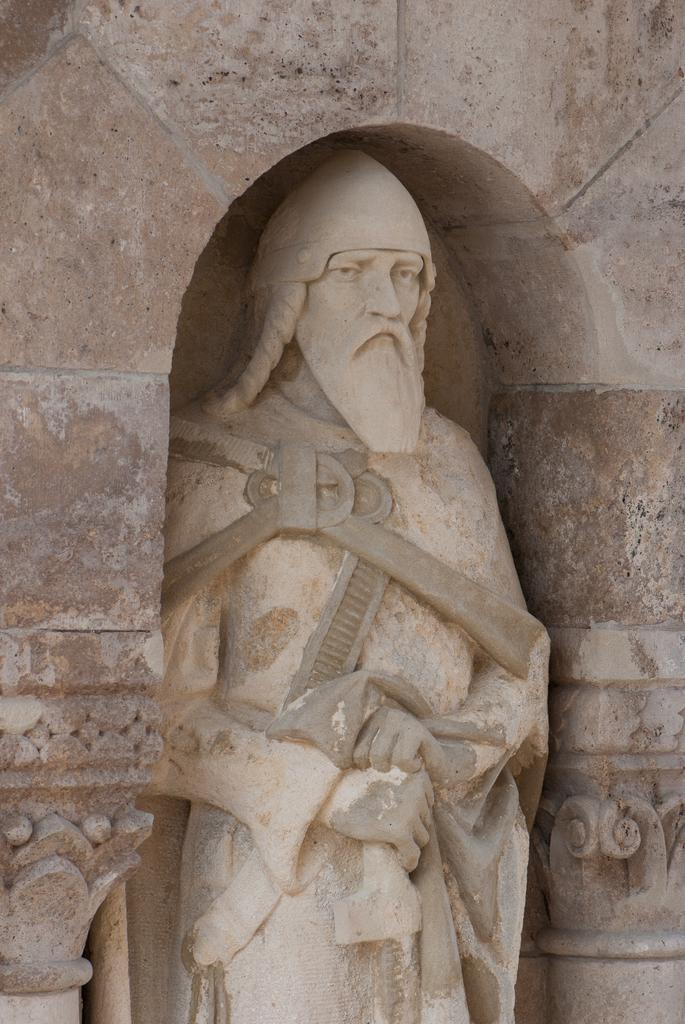How would you summarize this image in a sentence or two? In this image I can see a statue of a man. 